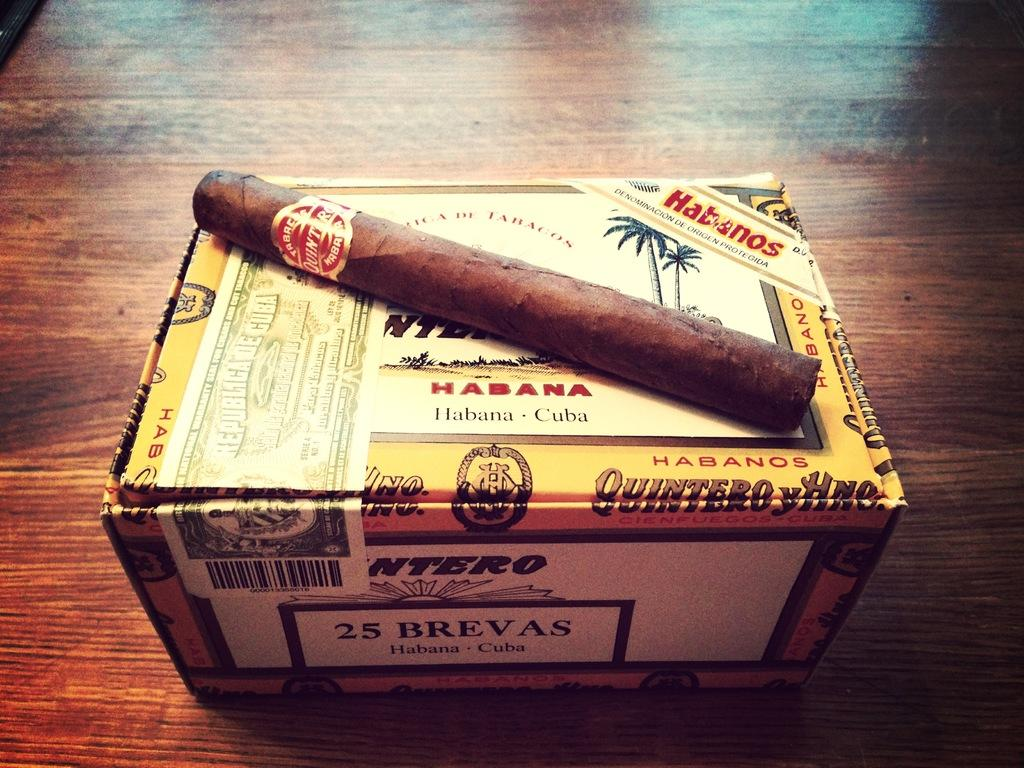Provide a one-sentence caption for the provided image. A Habana cigar that is sitting on a cigar box. 